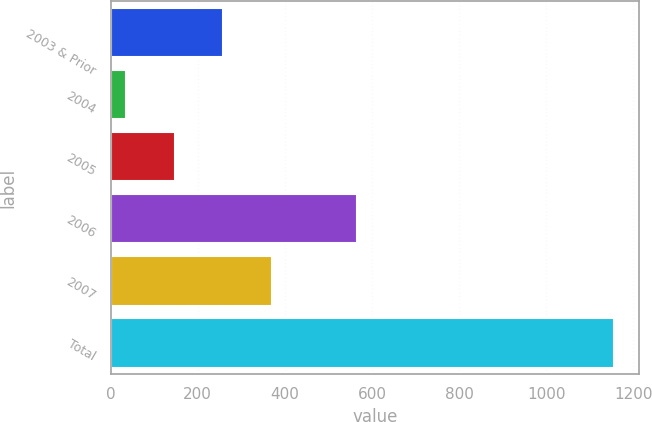<chart> <loc_0><loc_0><loc_500><loc_500><bar_chart><fcel>2003 & Prior<fcel>2004<fcel>2005<fcel>2006<fcel>2007<fcel>Total<nl><fcel>259.2<fcel>35<fcel>147.1<fcel>566<fcel>371.3<fcel>1156<nl></chart> 